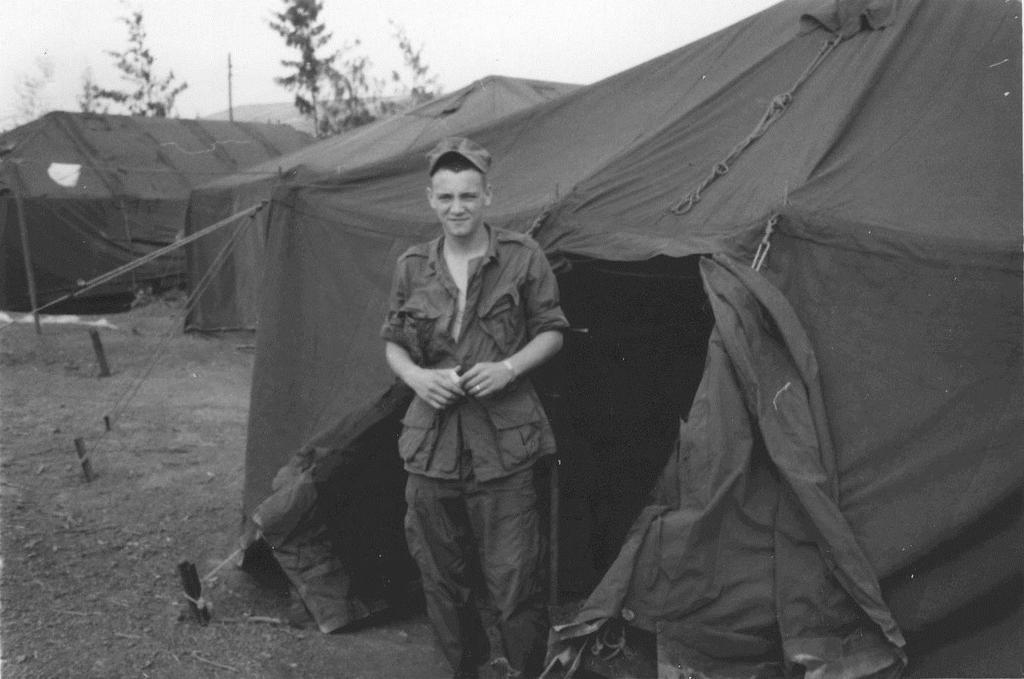Describe this image in one or two sentences. In this picture I can see few tents, trees and I can see a human standing, he is wearing a cap and a cloudy sky. 